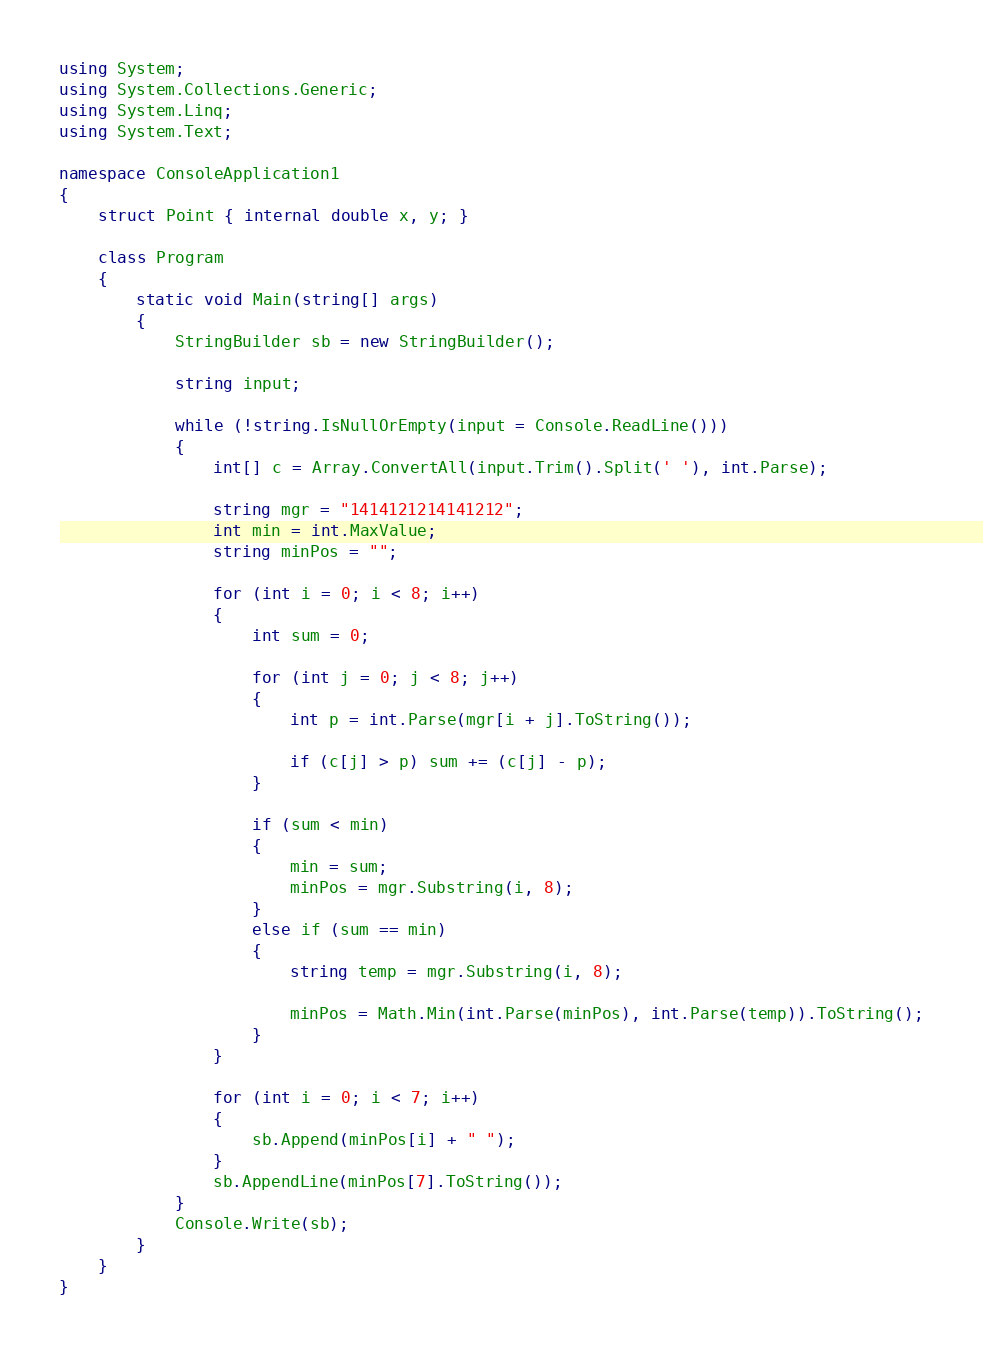Convert code to text. <code><loc_0><loc_0><loc_500><loc_500><_C#_>using System;
using System.Collections.Generic;
using System.Linq;
using System.Text;

namespace ConsoleApplication1
{
    struct Point { internal double x, y; }

    class Program
    {
        static void Main(string[] args)
        {
            StringBuilder sb = new StringBuilder();

            string input;

            while (!string.IsNullOrEmpty(input = Console.ReadLine()))
            {
                int[] c = Array.ConvertAll(input.Trim().Split(' '), int.Parse);

                string mgr = "1414121214141212";
                int min = int.MaxValue;
                string minPos = "";

                for (int i = 0; i < 8; i++)
                {
                    int sum = 0;

                    for (int j = 0; j < 8; j++)
                    {
                        int p = int.Parse(mgr[i + j].ToString());

                        if (c[j] > p) sum += (c[j] - p);
                    }

                    if (sum < min)
                    {
                        min = sum;
                        minPos = mgr.Substring(i, 8);
                    }
                    else if (sum == min)
                    {
                        string temp = mgr.Substring(i, 8);

                        minPos = Math.Min(int.Parse(minPos), int.Parse(temp)).ToString();
                    }
                }

                for (int i = 0; i < 7; i++)
                {
                    sb.Append(minPos[i] + " ");
                }
                sb.AppendLine(minPos[7].ToString());
            }
            Console.Write(sb);
        }
    }
}</code> 